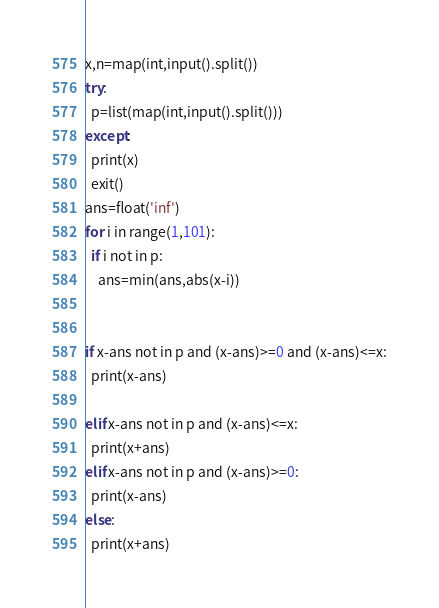<code> <loc_0><loc_0><loc_500><loc_500><_Python_>x,n=map(int,input().split())
try:
  p=list(map(int,input().split()))
except:
  print(x)
  exit()
ans=float('inf')
for i in range(1,101):
  if i not in p:
    ans=min(ans,abs(x-i))
    
    
if x-ans not in p and (x-ans)>=0 and (x-ans)<=x:
  print(x-ans)
  
elif x-ans not in p and (x-ans)<=x:
  print(x+ans)
elif x-ans not in p and (x-ans)>=0:
  print(x-ans)
else:
  print(x+ans)</code> 